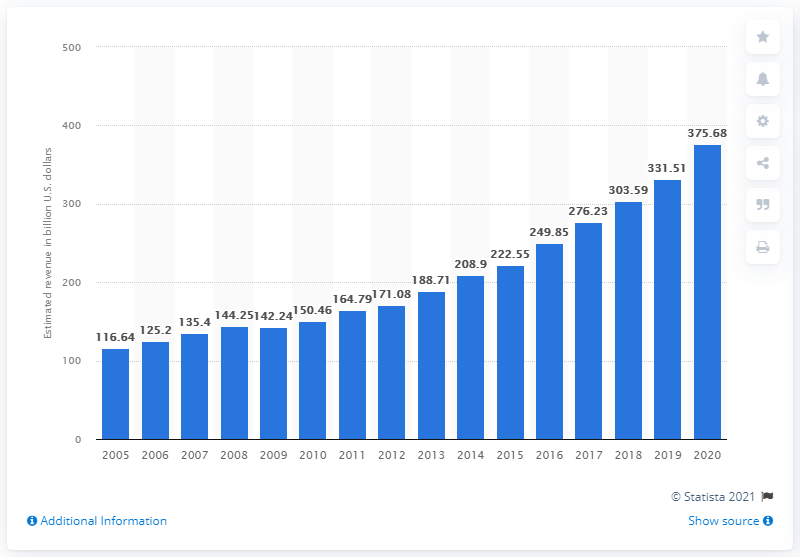Draw attention to some important aspects in this diagram. In 2020, software publishers in the United States generated a total revenue of 375.68 million dollars. 